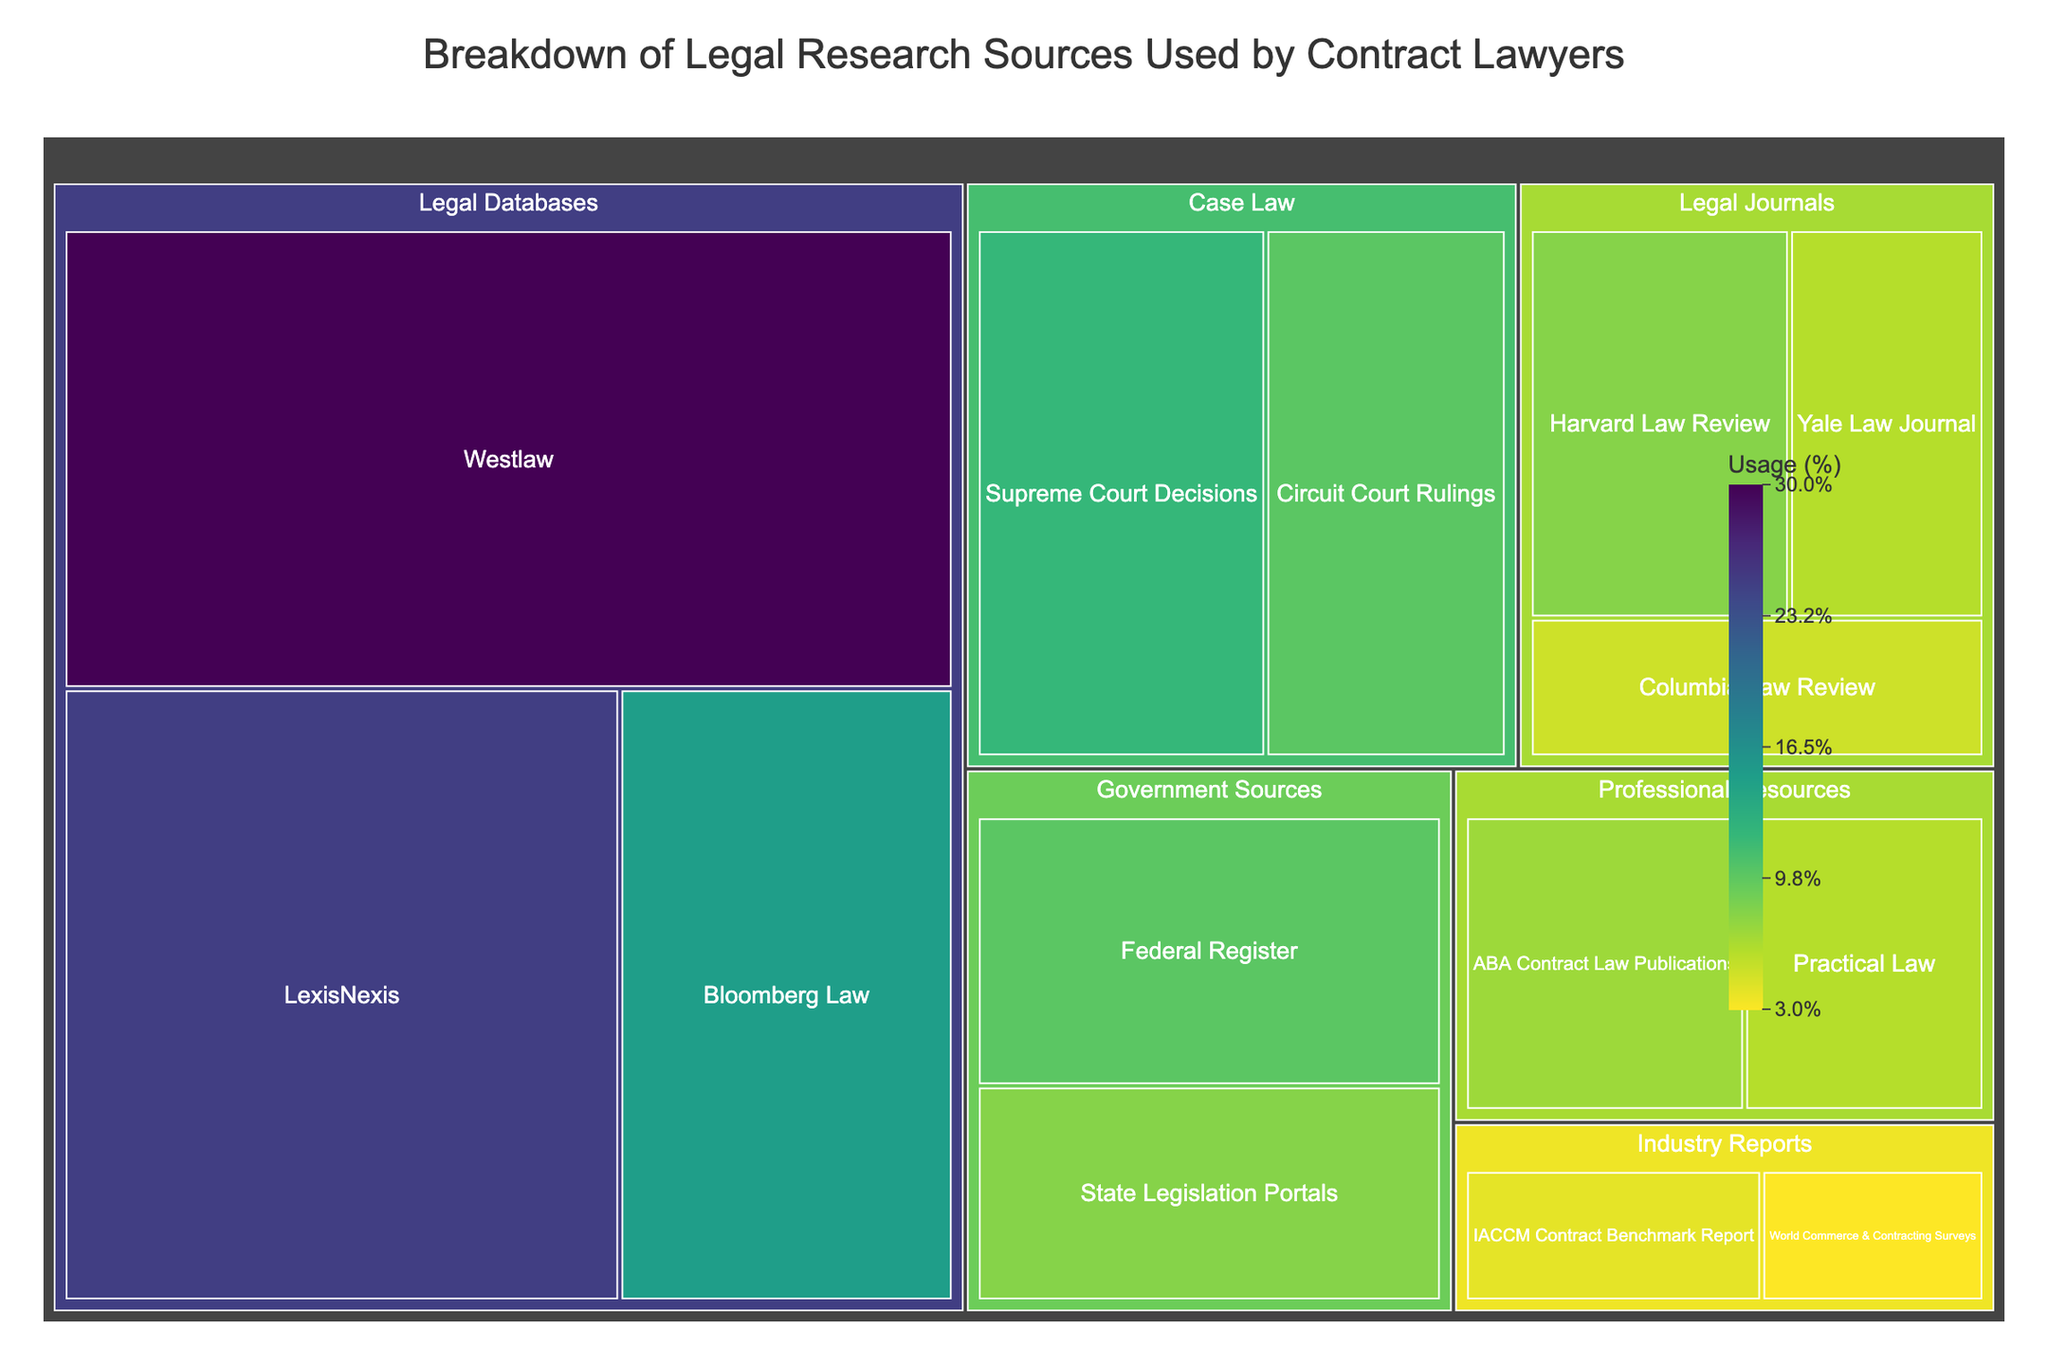What is the title of the figure? The title of a figure is usually displayed at the top. In this case, it is "Breakdown of Legal Research Sources Used by Contract Lawyers" as provided in the code and data.
Answer: Breakdown of Legal Research Sources Used by Contract Lawyers Which subcategory has the highest value in the Legal Databases category? In the Legal Databases category, the subcategory with the highest value is the one with the largest proportion in the treemap. Referring to the data, Westlaw has the highest value of 30.
Answer: Westlaw How many categories are listed in the figure? The number of categories can be counted by looking at the main sections in the treemap. Based on the data, there are five categories: Legal Databases, Legal Journals, Government Sources, Professional Resources, and Industry Reports.
Answer: Five What is the combined percentage of subcategories under Case Law? To find the combined percentage, sum the values of the subcategories under Case Law. According to the data, Supreme Court Decisions (12) + Circuit Court Rulings (10) = 22%.
Answer: 22% Which subcategory in Legal Journals has the lowest value? Within the Legal Journals category, the subcategory with the smallest proportion in the treemap is identified from the data. Columbia Law Review has the lowest value of 5.
Answer: Columbia Law Review How does the usage of Federal Register compare to State Legislation Portals? By comparing their values, Federal Register has a value of 10 and State Legislation Portals has a value of 8. Federal Register has a higher value.
Answer: Federal Register is higher What is the average value of the Professional Resources subcategories? To find the average value, sum the values of the subcategories in Professional Resources and then divide by the number of subcategories. (ABA Contract Law Publications (7) + Practical Law (6) = 13) / 2 = 6.5.
Answer: 6.5 Which category has more total usage, Government Sources or Case Law? Sum the values of the subcategories in each category and compare. Government Sources: Federal Register (10) + State Legislation Portals (8) = 18. Case Law: Supreme Court Decisions (12) + Circuit Court Rulings (10) = 22. Case Law has more total usage.
Answer: Case Law Compare the total usage differences between Legal Databases and Legal Journals categories. Sum the values of the subcategories in each category and find the difference. Legal Databases: Westlaw (30) + LexisNexis (25) + Bloomberg Law (15) = 70. Legal Journals: Harvard Law Review (8) + Yale Law Journal (6) + Columbia Law Review (5) = 19. The difference is 70 - 19 = 51.
Answer: 51 Which subcategory in Industry Reports holds a larger share? Compare the values of subcategories within Industry Reports. IACCM Contract Benchmark Report has 4 and World Commerce & Contracting Surveys has 3, so IACCM Contract Benchmark Report holds a larger share.
Answer: IACCM Contract Benchmark Report 